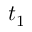Convert formula to latex. <formula><loc_0><loc_0><loc_500><loc_500>t _ { 1 }</formula> 